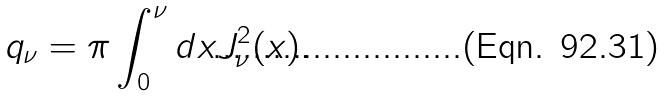Convert formula to latex. <formula><loc_0><loc_0><loc_500><loc_500>q _ { \nu } = \pi \int _ { 0 } ^ { \nu } d x J _ { \nu } ^ { 2 } ( x ) .</formula> 